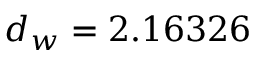Convert formula to latex. <formula><loc_0><loc_0><loc_500><loc_500>d _ { w } = 2 . 1 6 3 2 6</formula> 